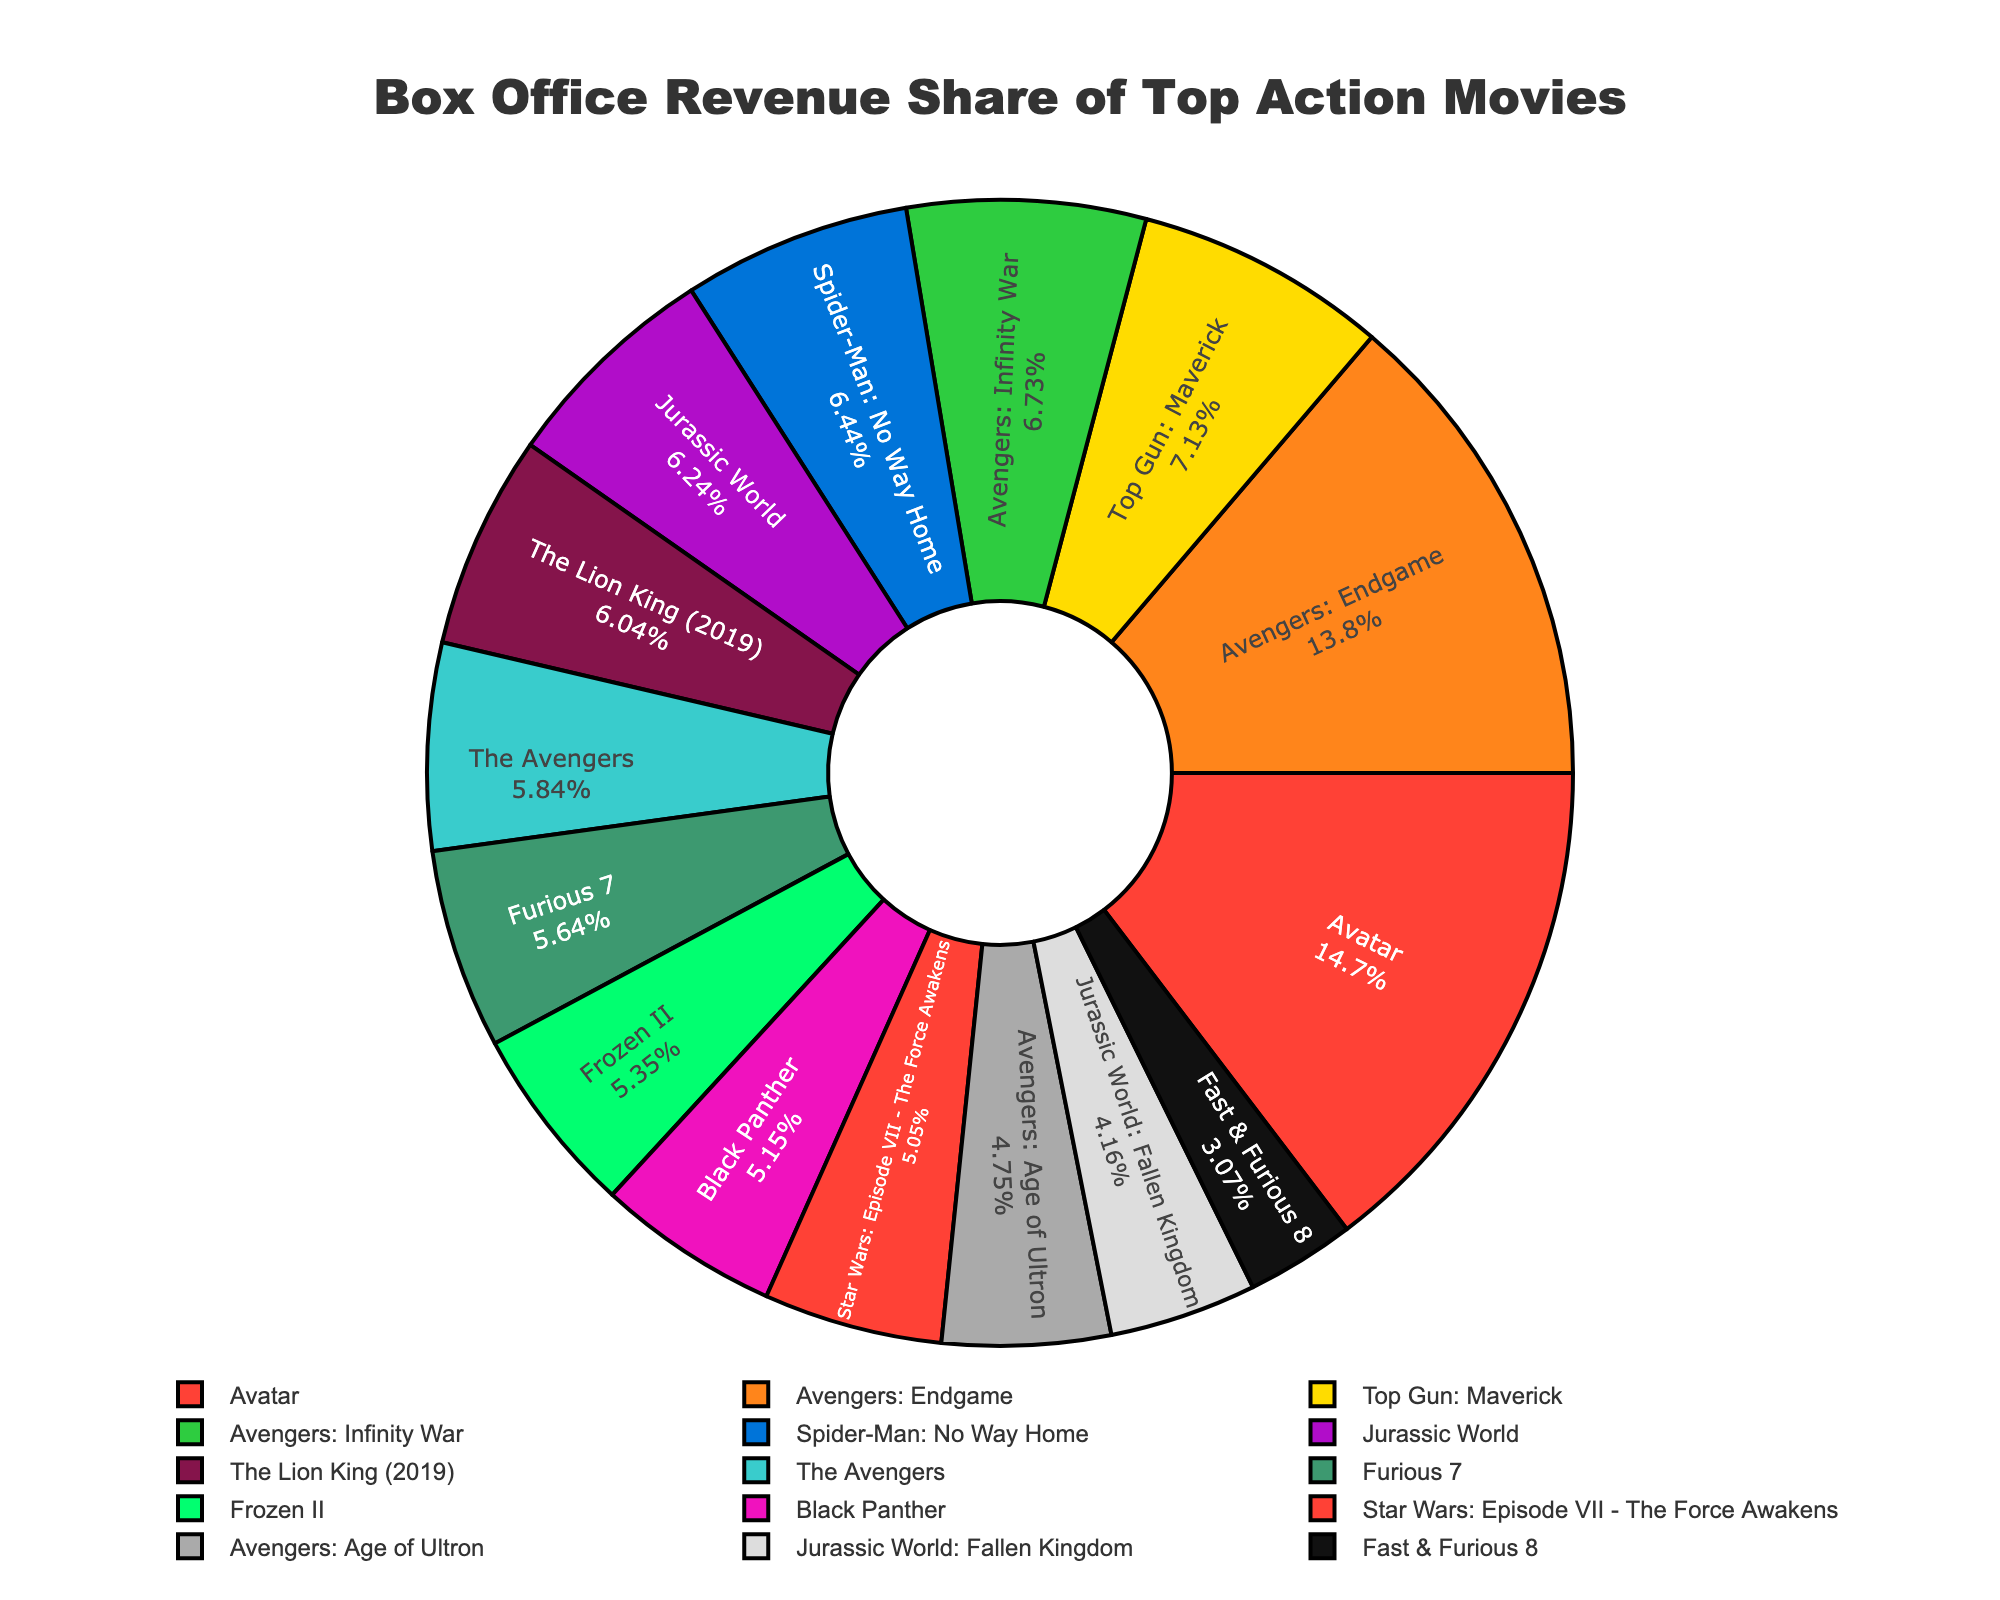Which movie has the largest revenue share? The movie with the largest revenue share is represented by the largest slice in the pie chart, which is "Avatar".
Answer: Avatar How much bigger is the revenue share of "Avatar" compared to "Black Panther"? The revenue share of "Avatar" is 14.8%, and "Black Panther" is 5.2%. The difference is 14.8% - 5.2% = 9.6%.
Answer: 9.6% Which movie has a similar revenue share to "Frozen II"? "Star Wars: Episode VII - The Force Awakens" has a revenue share very close to "Frozen II". Both are around 5.4% and 5.1% respectively.
Answer: Star Wars: Episode VII - The Force Awakens What is the total revenue share of "Avengers" related movies in the chart? "Avengers: Endgame" (13.9%), "Avengers: Infinity War" (6.8%), "The Avengers" (5.9%), and "Avengers: Age of Ultron" (4.8%) are related. Summing them up: 13.9% + 6.8% + 5.9% + 4.8% = 31.4%.
Answer: 31.4% Which movie's revenue share is the second-highest? The movie with the second-highest revenue share is represented by the second-largest slice in the pie chart, which is "Avengers: Endgame" with 13.9%.
Answer: Avengers: Endgame What is the combined revenue share of "Jurassic World" and "Jurassic World: Fallen Kingdom"? "Jurassic World" has a share of 6.3% and "Jurassic World: Fallen Kingdom" has 4.2%. Combined, it's 6.3% + 4.2% = 10.5%.
Answer: 10.5% Which slice represents "Furious 7" and what is its unique visual attribute? The slice for "Furious 7" is colored in purple and has a revenue share of 5.7%.
Answer: Purple, 5.7% How many movies have a revenue share greater than 10%? The movies with revenue shares greater than 10% are "Avatar" (14.8%) and "Avengers: Endgame" (13.9%), so there are 2 such movies.
Answer: 2 How does "Fast & Furious 8" compare to the average revenue share of all the movies? The average revenue share of the 15 movies is (sum of all shares) / 15. Summing them: 14.8 + 13.9 + 7.2 + 6.8 + 6.5 + 6.3 + 6.1 + 5.9 + 5.7 + 5.4 + 5.2 + 5.1 + 4.8 + 4.2 + 3.1 = 100%. The average is 100% / 15 = 6.67%. "Fast & Furious 8" has a share of 3.1%, which is lower than the average.
Answer: Lower Which movie has the smallest revenue share? The smallest slice, representing 3.1%, belongs to "Fast & Furious 8".
Answer: Fast & Furious 8 